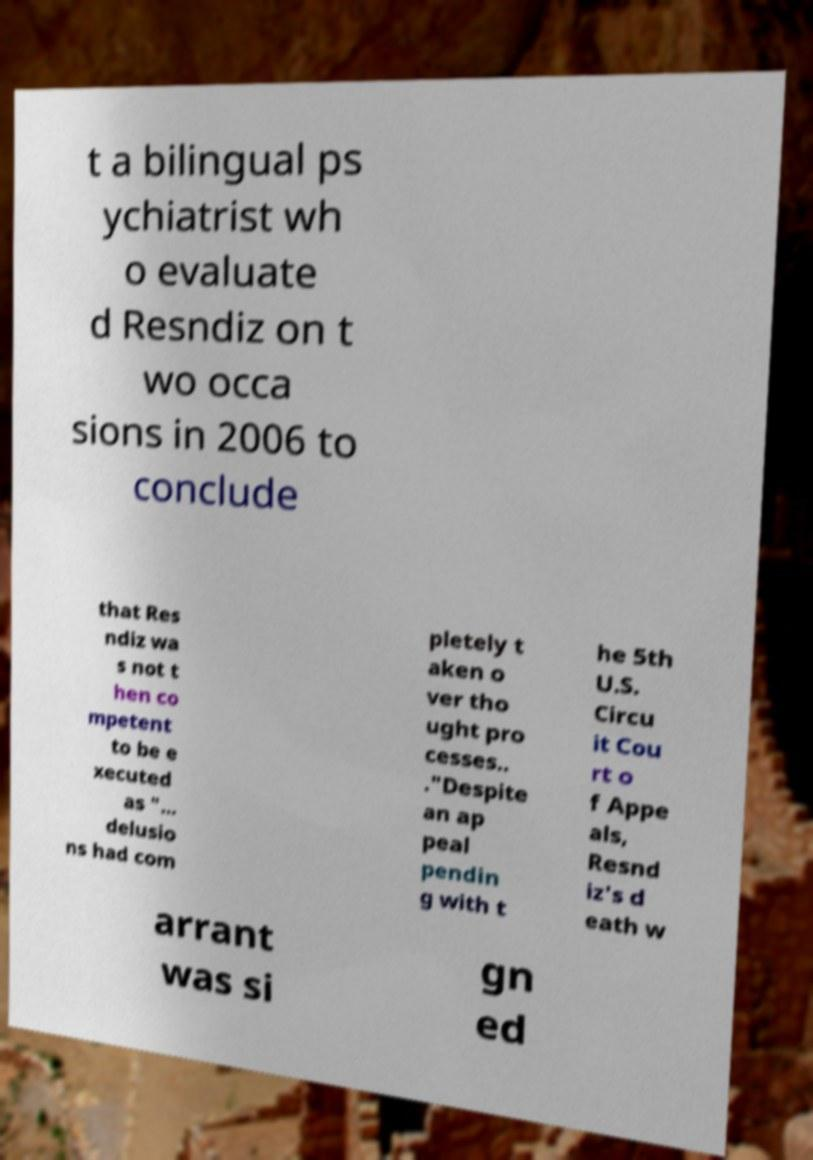Can you accurately transcribe the text from the provided image for me? t a bilingual ps ychiatrist wh o evaluate d Resndiz on t wo occa sions in 2006 to conclude that Res ndiz wa s not t hen co mpetent to be e xecuted as "... delusio ns had com pletely t aken o ver tho ught pro cesses.. ."Despite an ap peal pendin g with t he 5th U.S. Circu it Cou rt o f Appe als, Resnd iz's d eath w arrant was si gn ed 